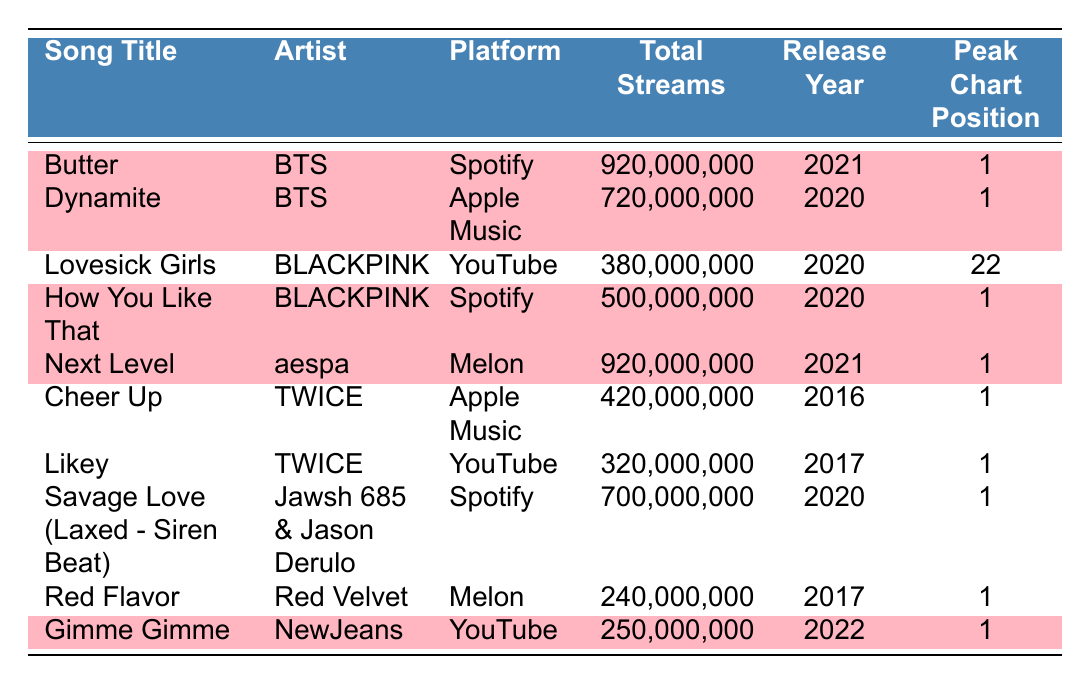What is the total number of streams for "Butter"? The table shows the total streams for "Butter" listed as 920,000,000
Answer: 920,000,000 Which platform has the song "How You Like That" by BLACKPINK? The table lists "How You Like That" under the platform "Spotify"
Answer: Spotify Who is the artist of the song "Gimme Gimme"? The song "Gimme Gimme" is performed by the artist "NewJeans" as indicated in the table
Answer: NewJeans What is the peak chart position of "Dynamite"? The peak chart position for "Dynamite" is listed as 1 in the table
Answer: 1 How many songs have over 800 million total streams? The total streams of "Butter" (920,000,000) and "Next Level" (920,000,000) are both over 800 million, which makes 2 songs
Answer: 2 Is "Lovesick Girls" by BLACKPINK highlighted in the table? The table indicates that "Lovesick Girls" is not highlighted, as its highlight value is false
Answer: No What is the difference in total streams between "Dynamite" and "Savage Love (Laxed - Siren Beat)"? The total streams for "Dynamite" is 720,000,000, and for "Savage Love (Laxed - Siren Beat)" is 700,000,000. The difference is 720,000,000 - 700,000,000 = 20,000,000
Answer: 20,000,000 Which artist has the most songs highlighted in the table? Upon reviewing the highlighted songs, BTS has 2 highlighted songs ("Butter" and "Dynamite"), while other artists have fewer or the same; thus, BTS is the artist with the most highlighted songs
Answer: BTS What percentage of the total streams for "Next Level" are achieved compared to "How You Like That"? The total number of streams for "Next Level" is 920,000,000, and for "How You Like That" is 500,000,000. The percentage is calculated as (500,000,000 / 920,000,000) * 100 = 54.35%.
Answer: 54.35% 